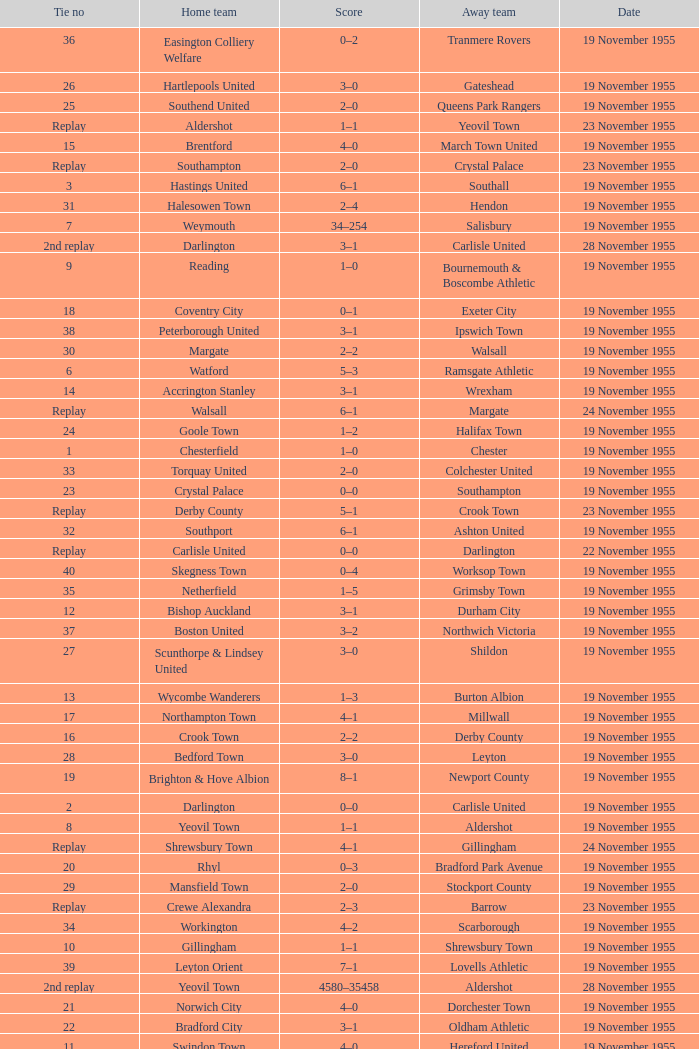What is the home team with scarborough as the away team? Workington. 